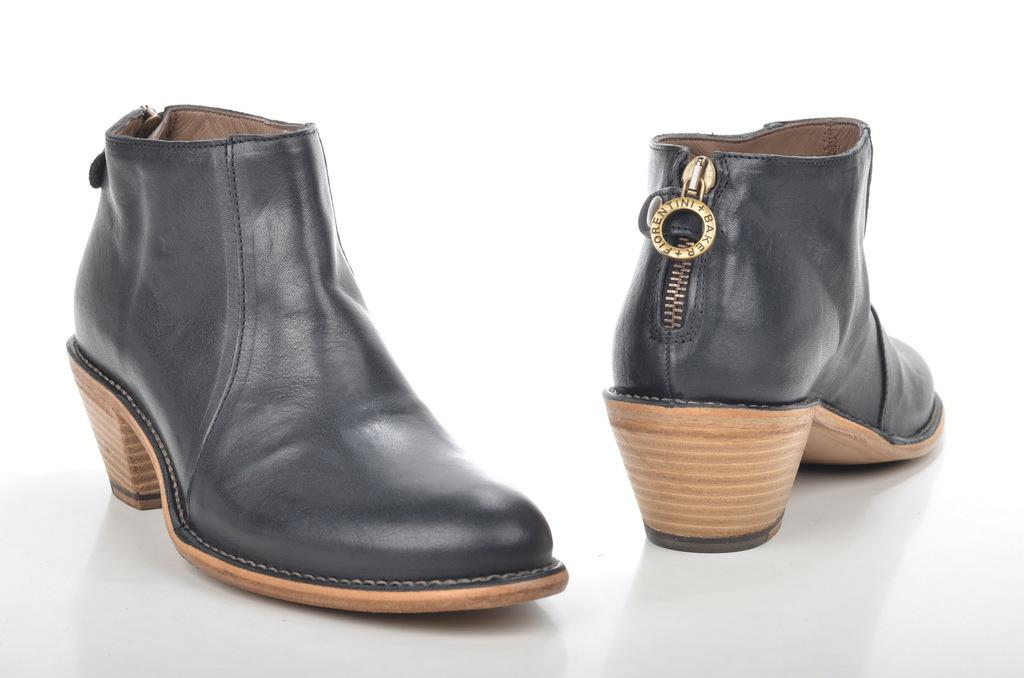How many shoes are visible in the image? There are 2 shoes in the image. What color are the shoes in the image? The shoes are black in color. What type of trouble can be seen in the image? There is no trouble present in the image; it features 2 black shoes. What flavor of jam can be seen in the image? There is no jam present in the image; it features 2 black shoes. 